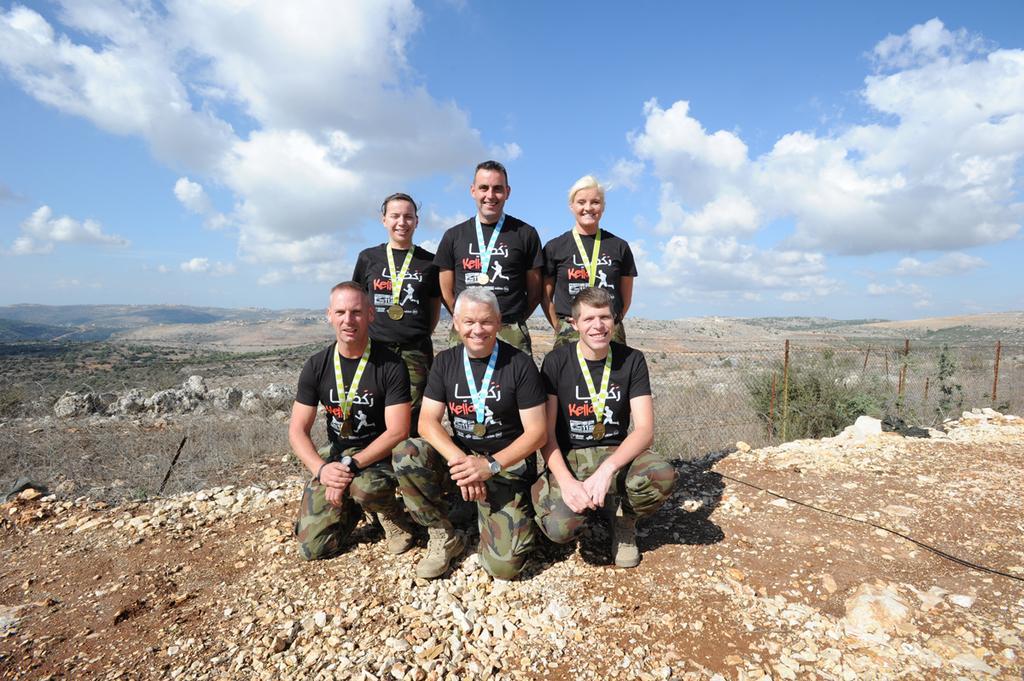How would you summarize this image in a sentence or two? In this picture we can observe five members. Four of them are men and the other is a woman. All of them are smiling. There are medals in their necks. We can observe some stones on the ground. In the background there are trees and a sky with some clouds. 